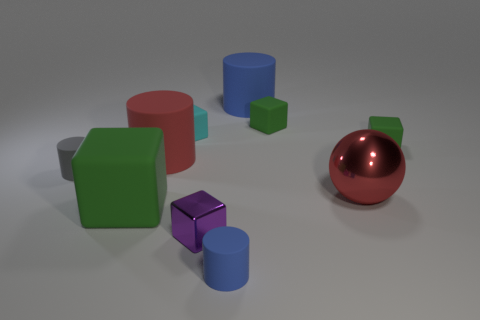There is a thing that is the same color as the large metallic sphere; what is its shape?
Give a very brief answer. Cylinder. Is the color of the metallic sphere the same as the big matte block?
Keep it short and to the point. No. There is a red matte thing in front of the thing to the right of the large red sphere; what number of cylinders are on the left side of it?
Keep it short and to the point. 1. There is a blue cylinder that is behind the big matte cylinder that is to the left of the tiny cyan rubber cube; what is it made of?
Your answer should be compact. Rubber. Are there any other gray objects that have the same shape as the tiny gray thing?
Keep it short and to the point. No. The other rubber cylinder that is the same size as the gray cylinder is what color?
Your answer should be very brief. Blue. What number of objects are either blue matte cylinders behind the tiny cyan rubber block or cylinders that are on the left side of the tiny cyan matte block?
Offer a very short reply. 3. How many objects are either purple rubber spheres or gray rubber cylinders?
Keep it short and to the point. 1. There is a green matte block that is both in front of the cyan rubber thing and on the right side of the big red cylinder; what size is it?
Offer a very short reply. Small. How many large objects have the same material as the tiny purple thing?
Ensure brevity in your answer.  1. 